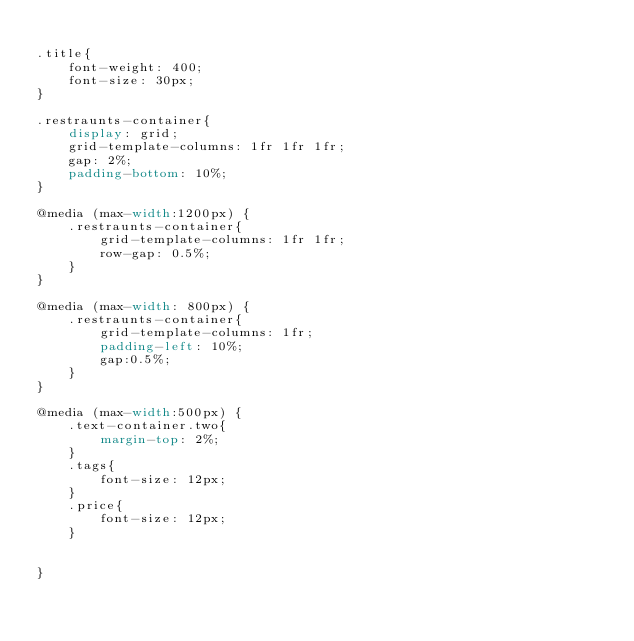<code> <loc_0><loc_0><loc_500><loc_500><_CSS_>
.title{
    font-weight: 400;
    font-size: 30px;
}

.restraunts-container{
    display: grid;
    grid-template-columns: 1fr 1fr 1fr;
    gap: 2%;
    padding-bottom: 10%;
}

@media (max-width:1200px) {
    .restraunts-container{
        grid-template-columns: 1fr 1fr;
        row-gap: 0.5%;
    }
}

@media (max-width: 800px) {
    .restraunts-container{
        grid-template-columns: 1fr;
        padding-left: 10%;
        gap:0.5%;
    }
}

@media (max-width:500px) {
    .text-container.two{
        margin-top: 2%;
    }
    .tags{
        font-size: 12px;
    }
    .price{
        font-size: 12px;
    }

    
}
</code> 